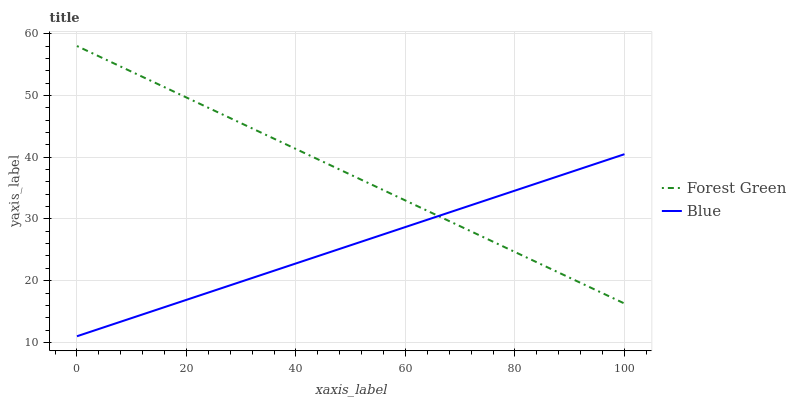Does Blue have the minimum area under the curve?
Answer yes or no. Yes. Does Forest Green have the maximum area under the curve?
Answer yes or no. Yes. Does Forest Green have the minimum area under the curve?
Answer yes or no. No. Is Blue the smoothest?
Answer yes or no. Yes. Is Forest Green the roughest?
Answer yes or no. Yes. Is Forest Green the smoothest?
Answer yes or no. No. Does Blue have the lowest value?
Answer yes or no. Yes. Does Forest Green have the lowest value?
Answer yes or no. No. Does Forest Green have the highest value?
Answer yes or no. Yes. Does Blue intersect Forest Green?
Answer yes or no. Yes. Is Blue less than Forest Green?
Answer yes or no. No. Is Blue greater than Forest Green?
Answer yes or no. No. 